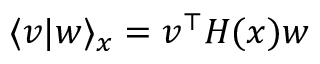<formula> <loc_0><loc_0><loc_500><loc_500>\langle v | w \rangle _ { x } = v ^ { \top } H ( x ) w</formula> 